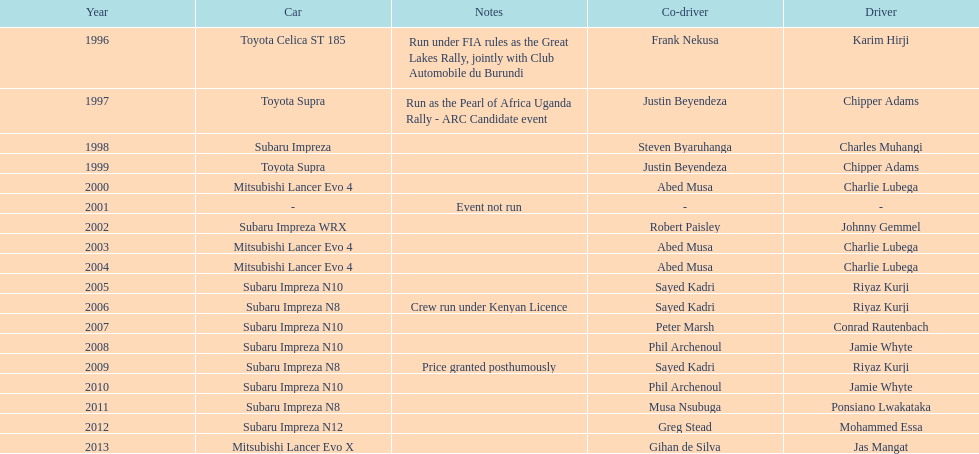What is the total number of times that the winning driver was driving a toyota supra? 2. 